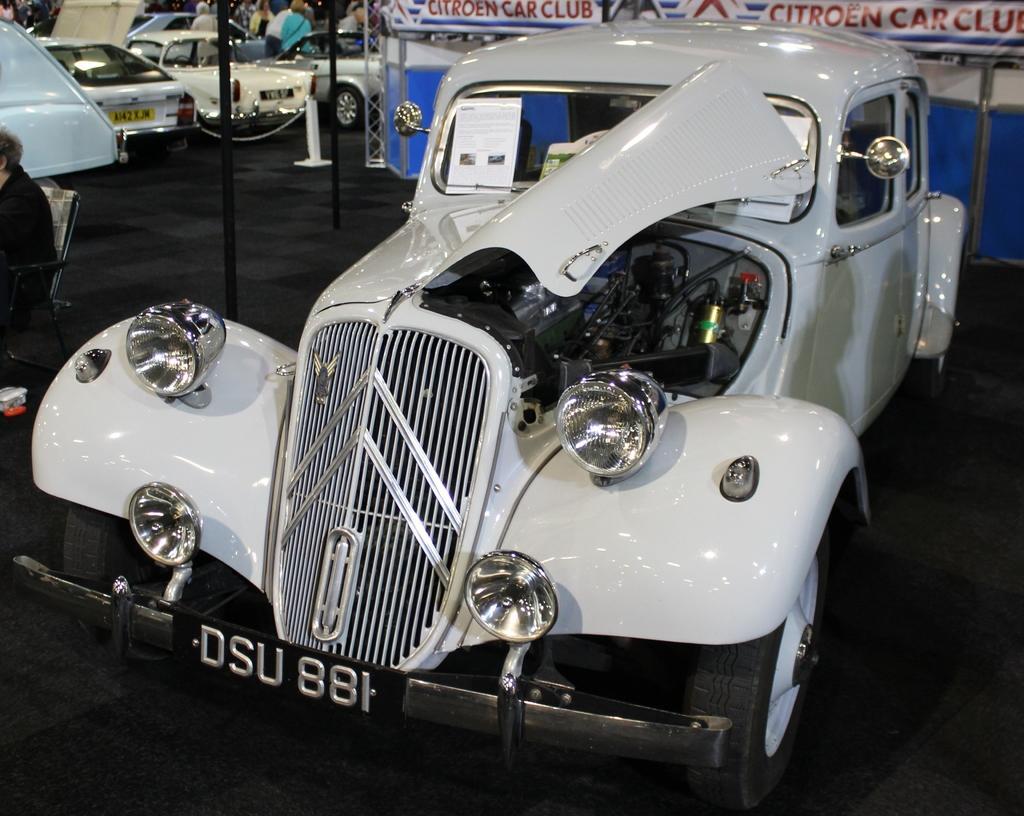Can you describe this image briefly? In this image in the center there is one car and engine, and in the background there are some cars and some people are standing. On the left side there is one person who is sitting on a chair, and also there are some poles. At the bottom there is a floor. 